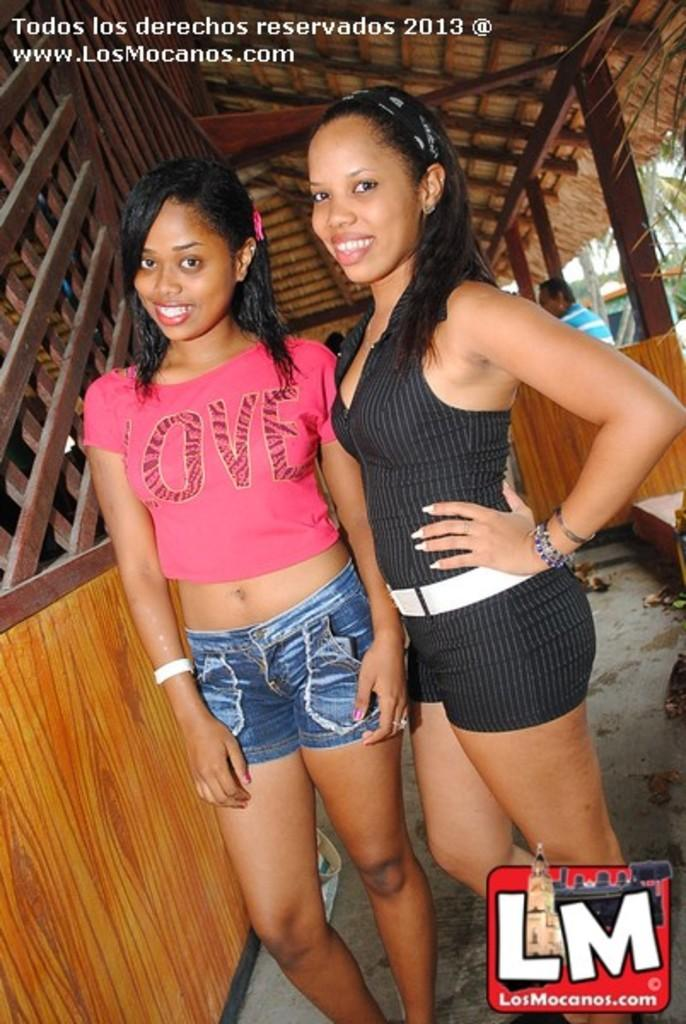How many people are in the image? There are two girls in the image. What are the girls doing in the image? The girls are standing and smiling. What can be seen on the left side of the image? There is a wooden board on the left side of the image. What type of structure is visible at the top of the image? There is a shed at the top of the image. What color is the woman's dress in the image? There is no woman present in the image, only two girls. How does the shed shake in the image? The shed does not shake in the image; it is stationary. 